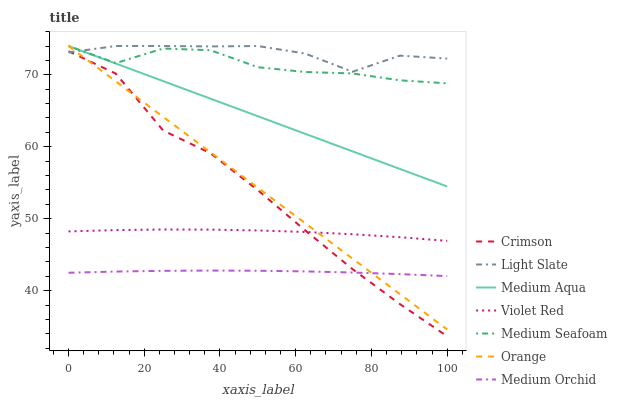Does Light Slate have the minimum area under the curve?
Answer yes or no. No. Does Medium Orchid have the maximum area under the curve?
Answer yes or no. No. Is Light Slate the smoothest?
Answer yes or no. No. Is Light Slate the roughest?
Answer yes or no. No. Does Medium Orchid have the lowest value?
Answer yes or no. No. Does Medium Orchid have the highest value?
Answer yes or no. No. Is Medium Orchid less than Light Slate?
Answer yes or no. Yes. Is Light Slate greater than Medium Orchid?
Answer yes or no. Yes. Does Medium Orchid intersect Light Slate?
Answer yes or no. No. 